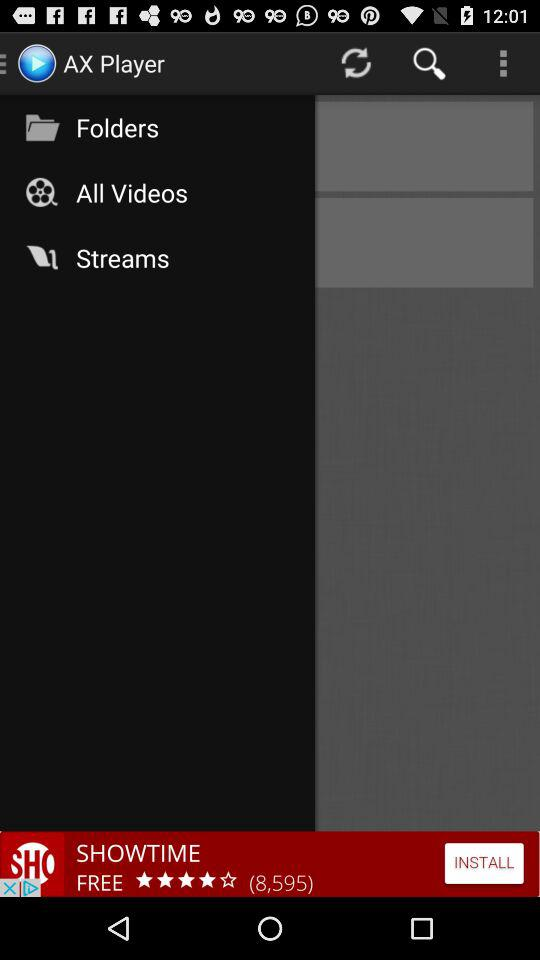What is the name of the application? The name of the application is "AX Player". 